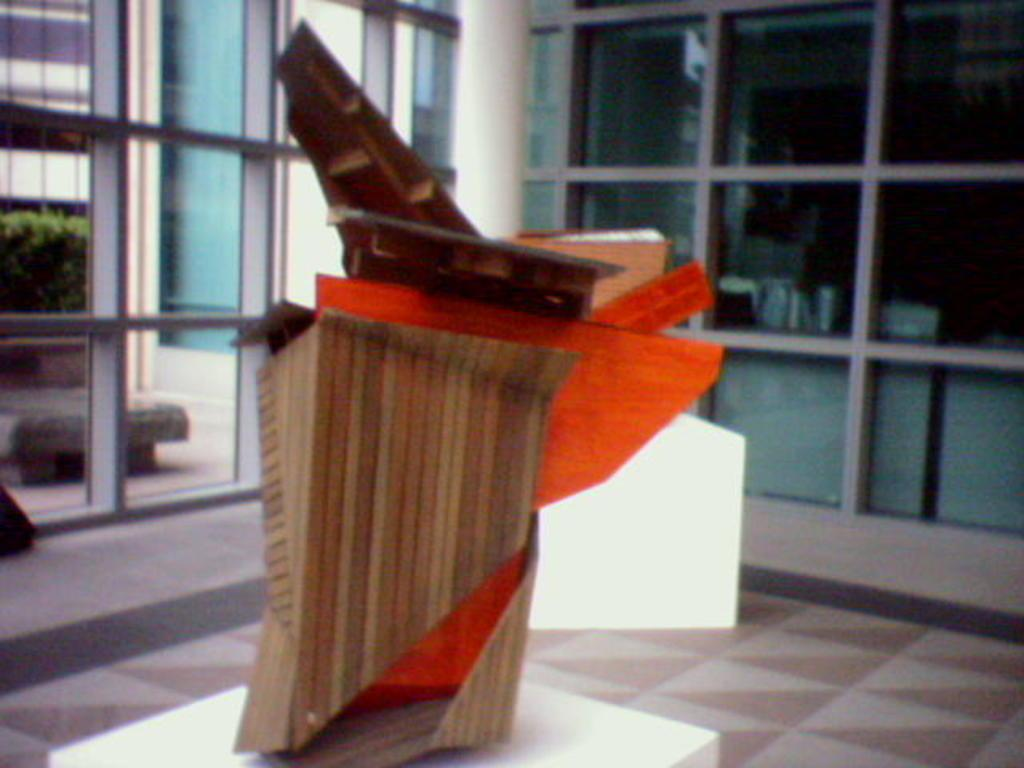What is located in the foreground of the image? There are objects on a table in the foreground. What can be seen in the background of the image? There is a wall, a glass window, a cabinet, a bench, trees, and buildings in the background. Can you describe the setting of the image? The image may have been taken in a hall, as suggested by the presence of a table and various background elements. What type of stem is growing from the table in the image? There is no stem growing from the table in the image. What idea does the bench represent in the image? The image does not convey any specific ideas or concepts related to the bench. 